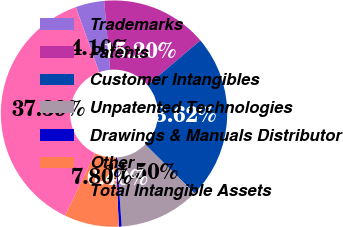Convert chart. <chart><loc_0><loc_0><loc_500><loc_500><pie_chart><fcel>Trademarks<fcel>Patents<fcel>Customer Intangibles<fcel>Unpatented Technologies<fcel>Drawings & Manuals Distributor<fcel>Other<fcel>Total Intangible Assets<nl><fcel>4.1%<fcel>15.2%<fcel>23.62%<fcel>11.5%<fcel>0.4%<fcel>7.8%<fcel>37.39%<nl></chart> 